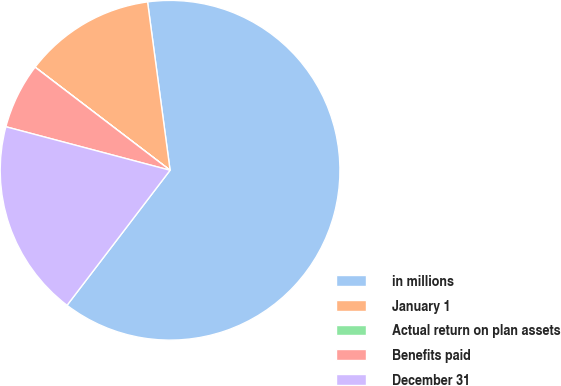Convert chart. <chart><loc_0><loc_0><loc_500><loc_500><pie_chart><fcel>in millions<fcel>January 1<fcel>Actual return on plan assets<fcel>Benefits paid<fcel>December 31<nl><fcel>62.49%<fcel>12.5%<fcel>0.01%<fcel>6.25%<fcel>18.75%<nl></chart> 